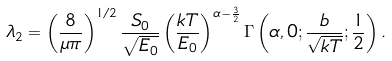Convert formula to latex. <formula><loc_0><loc_0><loc_500><loc_500>\lambda _ { 2 } = \left ( \frac { 8 } { \mu \pi } \right ) ^ { 1 / 2 } \frac { S _ { 0 } } { \sqrt { E _ { 0 } } } \left ( \frac { k T } { E _ { 0 } } \right ) ^ { \alpha - \frac { 3 } { 2 } } \Gamma \left ( \alpha , 0 ; \frac { b } { \sqrt { k T } } ; \frac { 1 } { 2 } \right ) .</formula> 